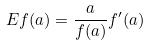Convert formula to latex. <formula><loc_0><loc_0><loc_500><loc_500>E f ( a ) = \frac { a } { f ( a ) } f ^ { \prime } ( a )</formula> 